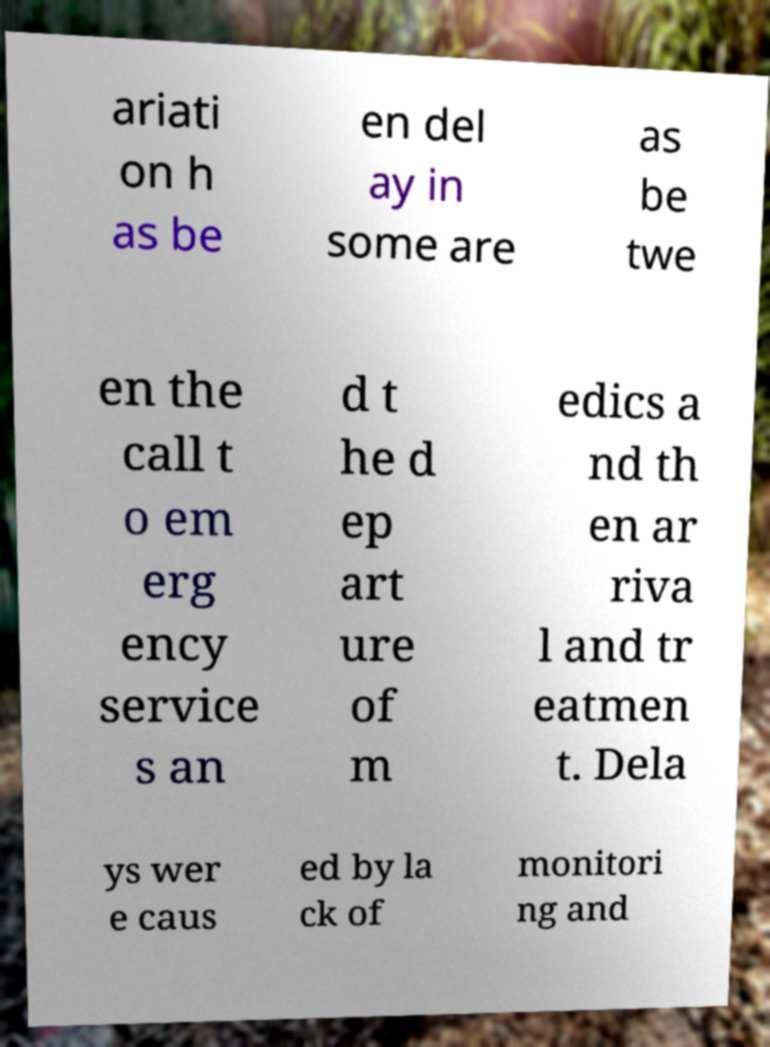Could you extract and type out the text from this image? ariati on h as be en del ay in some are as be twe en the call t o em erg ency service s an d t he d ep art ure of m edics a nd th en ar riva l and tr eatmen t. Dela ys wer e caus ed by la ck of monitori ng and 